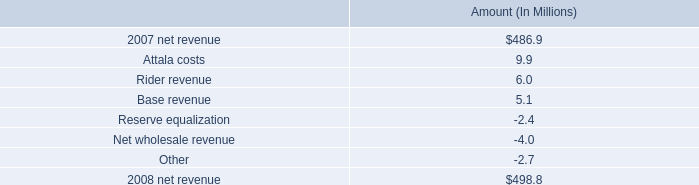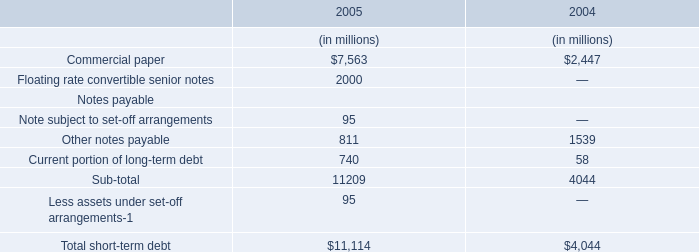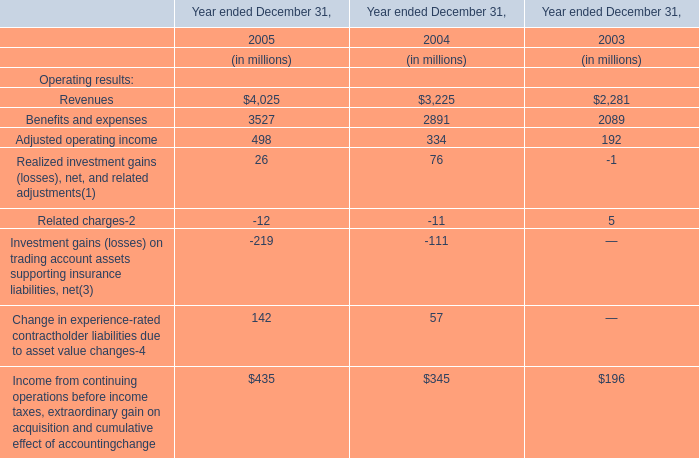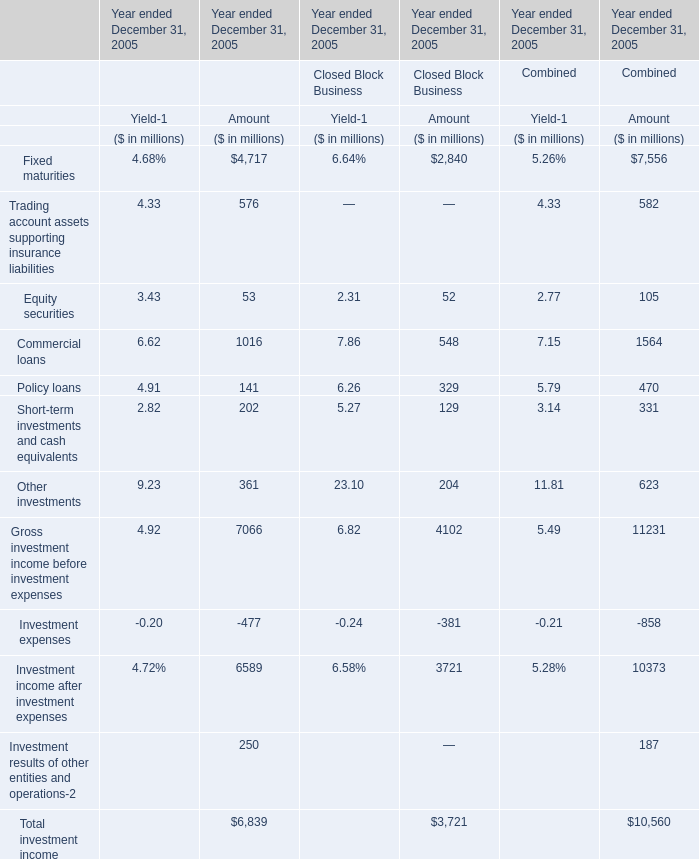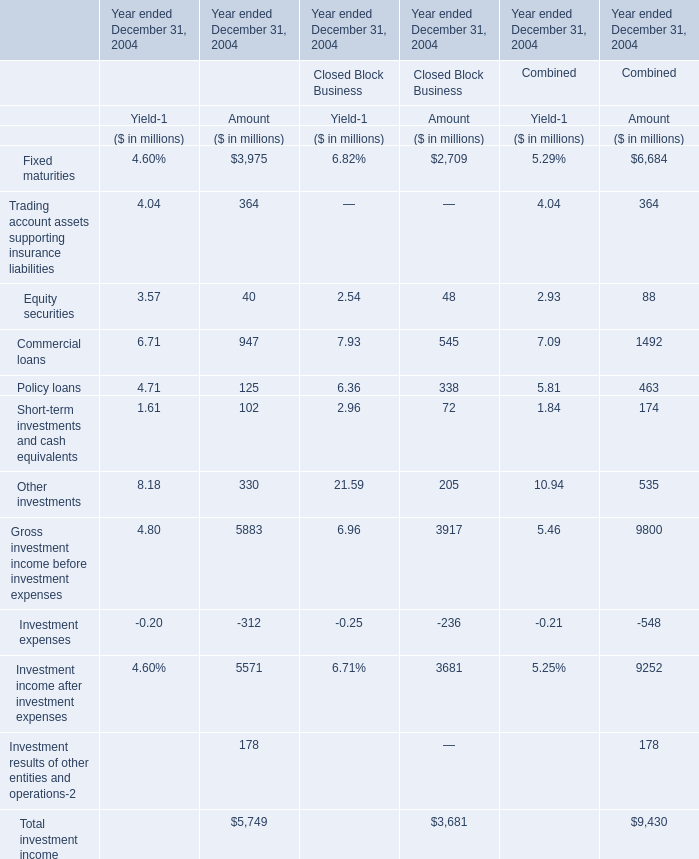In the section with largest amount of Fixed maturities, what's the sum of Equity securities Trading account assets supporting insurance liabilities for amount ? (in million) 
Computations: (40 + 364)
Answer: 404.0. 